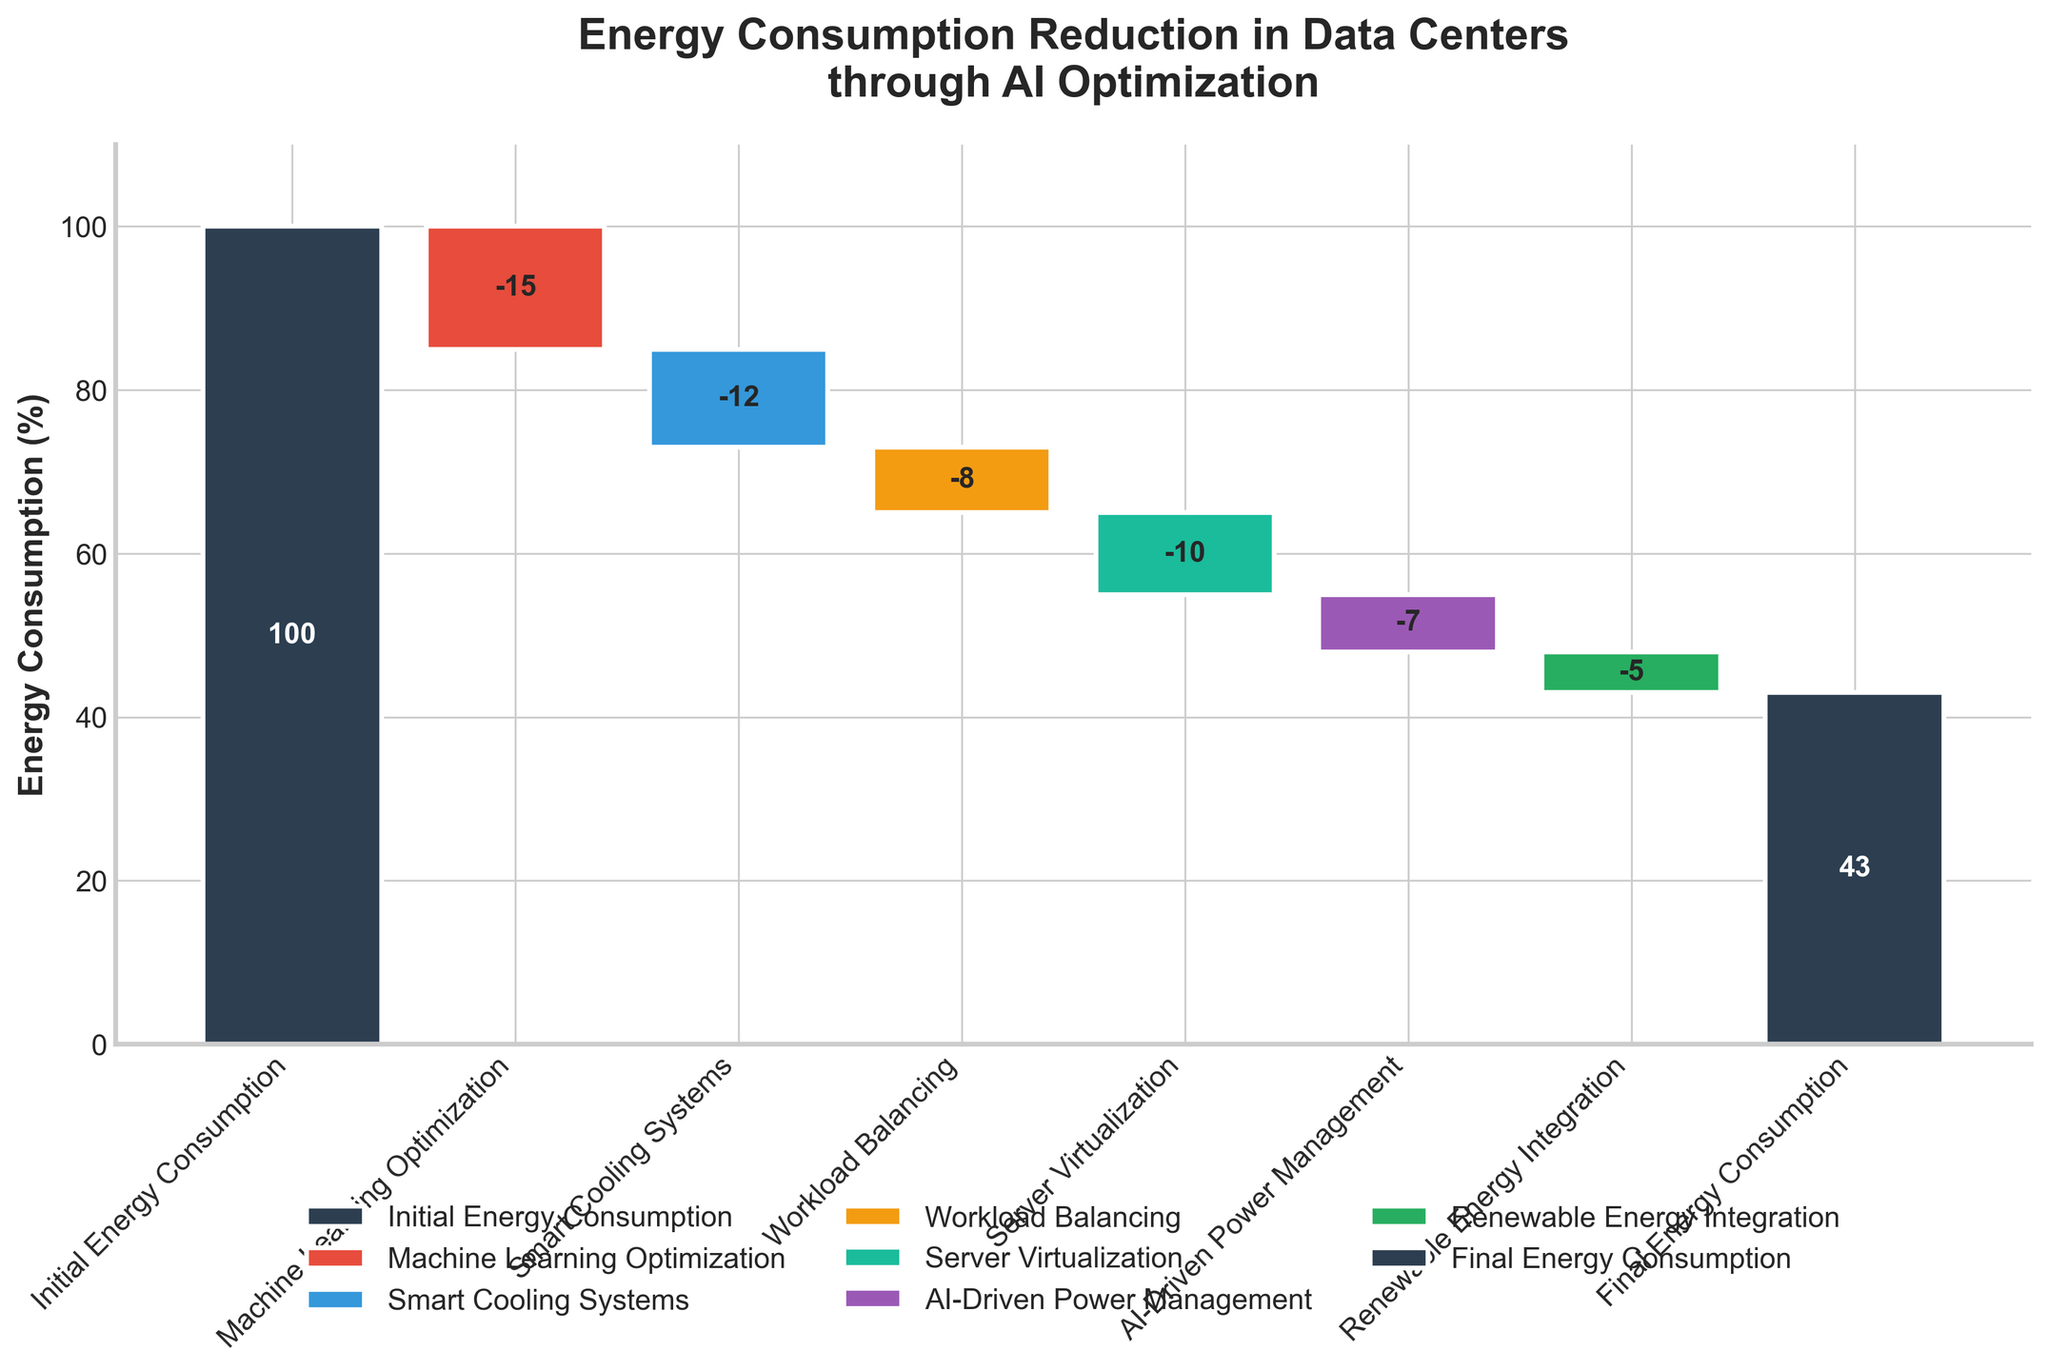What is the initial energy consumption according to the figure? The initial energy consumption is represented by the first bar on the chart, labeled "Initial Energy Consumption." The value shown at the center of the bar indicates the initial energy consumption.
Answer: 100% What is the total reduction in energy consumption from Machine Learning Optimization and Smart Cooling Systems combined? The reduction from Machine Learning Optimization is -15% and from Smart Cooling Systems is -12%. Adding these reductions together gives -15 + -12 = -27%.
Answer: -27% Which optimization technique contributed the least to energy reduction? By examining the chart, the smallest bar in terms of absolute value among the reduction bars indicates the smallest contribution. The value for Renewable Energy Integration is -5%, which is the smallest.
Answer: Renewable Energy Integration How much additional reduction is needed after using AI-Driven Power Management to achieve a final energy consumption of 30%? The current final energy consumption after AI-Driven Power Management (and all prior reductions) is 43%. To reach 30%, a further reduction of 43% - 30% = 13% is needed.
Answer: 13% Which technique follows Smart Cooling Systems in the sequence of energy consumption reduction steps? Smart Cooling Systems is the second step in the sequence. The next step, following it, is Workload Balancing.
Answer: Workload Balancing What is the total energy reduction achieved by all optimization techniques combined? The total energy reduction is calculated by adding all the reductions: -15 (Machine Learning Optimization) + -12 (Smart Cooling Systems) + -8 (Workload Balancing) + -10 (Server Virtualization) + -7 (AI-Driven Power Management) + -5 (Renewable Energy Integration) = -57%.
Answer: -57% What is the final energy consumption after all optimizations compared to the initial consumption? The final energy consumption is shown by the last bar labeled "Final Energy Consumption," which has a value of 43%. This shows that the final energy consumption is 43% of the initial 100%.
Answer: 43% Which optimization technique has the highest impact on reducing the energy consumption? The largest negative value in the chart represents the highest reduction, which is given by Machine Learning Optimization with a value of -15%.
Answer: Machine Learning Optimization 